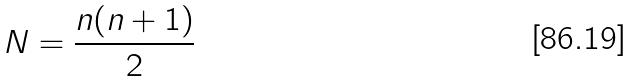<formula> <loc_0><loc_0><loc_500><loc_500>N = \frac { n ( n + 1 ) } { 2 }</formula> 